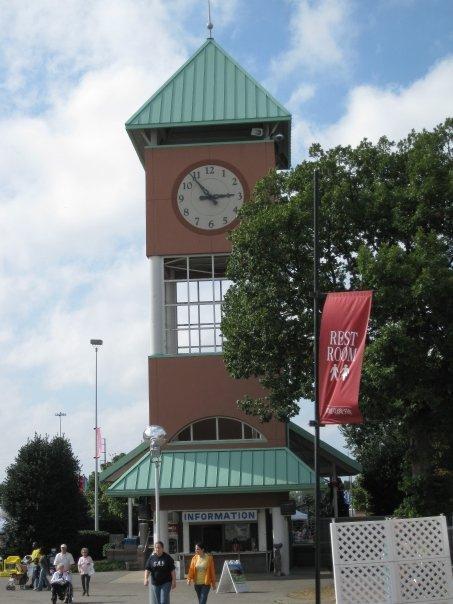How many stars on are on the flags?
Give a very brief answer. 0. 